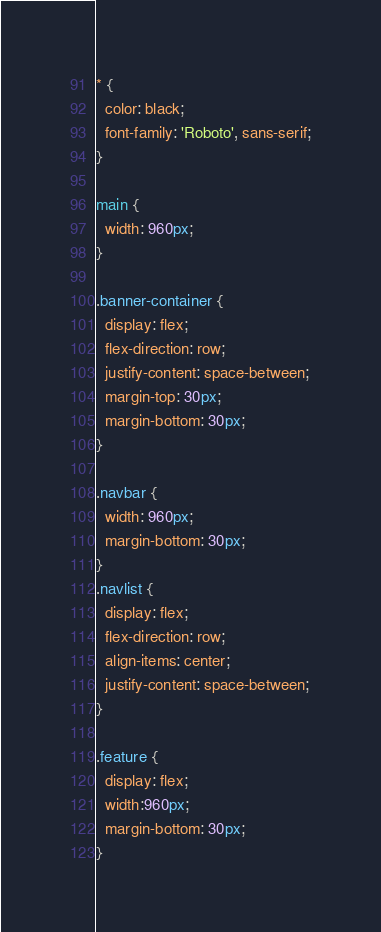Convert code to text. <code><loc_0><loc_0><loc_500><loc_500><_CSS_>* {
  color: black;
  font-family: 'Roboto', sans-serif;
}

main {
  width: 960px;
}

.banner-container {
  display: flex;
  flex-direction: row;
  justify-content: space-between;
  margin-top: 30px;
  margin-bottom: 30px;
}

.navbar {
  width: 960px;
  margin-bottom: 30px;
}
.navlist {
  display: flex;
  flex-direction: row;
  align-items: center;
  justify-content: space-between;
}

.feature {
  display: flex;
  width:960px;
  margin-bottom: 30px;
}
</code> 